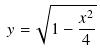Convert formula to latex. <formula><loc_0><loc_0><loc_500><loc_500>y = \sqrt { 1 - \frac { x ^ { 2 } } { 4 } }</formula> 